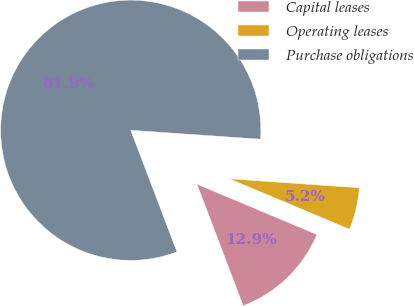<chart> <loc_0><loc_0><loc_500><loc_500><pie_chart><fcel>Capital leases<fcel>Operating leases<fcel>Purchase obligations<nl><fcel>12.89%<fcel>5.23%<fcel>81.88%<nl></chart> 